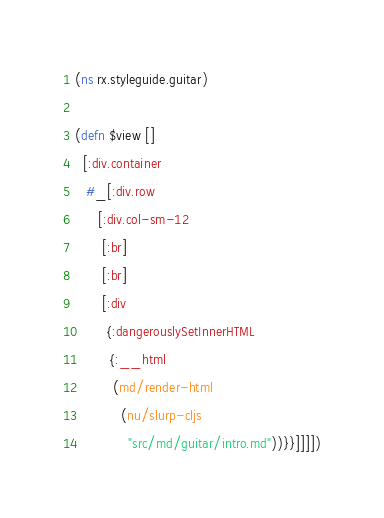Convert code to text. <code><loc_0><loc_0><loc_500><loc_500><_Clojure_>(ns rx.styleguide.guitar)

(defn $view []
  [:div.container
   #_[:div.row
      [:div.col-sm-12
       [:br]
       [:br]
       [:div
        {:dangerouslySetInnerHTML
         {:__html
          (md/render-html
            (nu/slurp-cljs
              "src/md/guitar/intro.md"))}}]]]])
</code> 